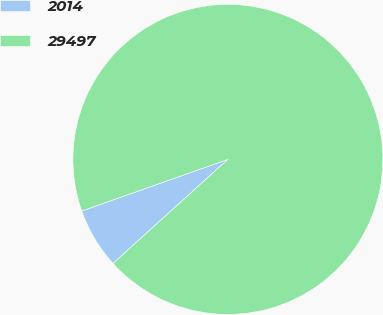<chart> <loc_0><loc_0><loc_500><loc_500><pie_chart><fcel>2014<fcel>29497<nl><fcel>6.31%<fcel>93.69%<nl></chart> 